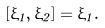<formula> <loc_0><loc_0><loc_500><loc_500>[ \xi _ { 1 } , \xi _ { 2 } ] = \xi _ { 1 } .</formula> 